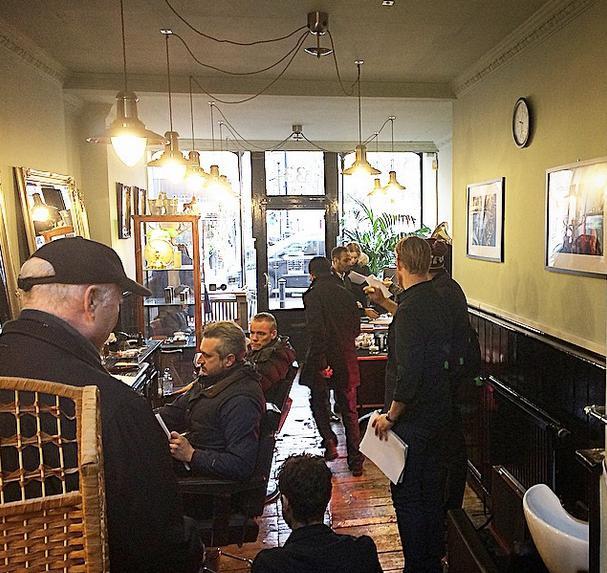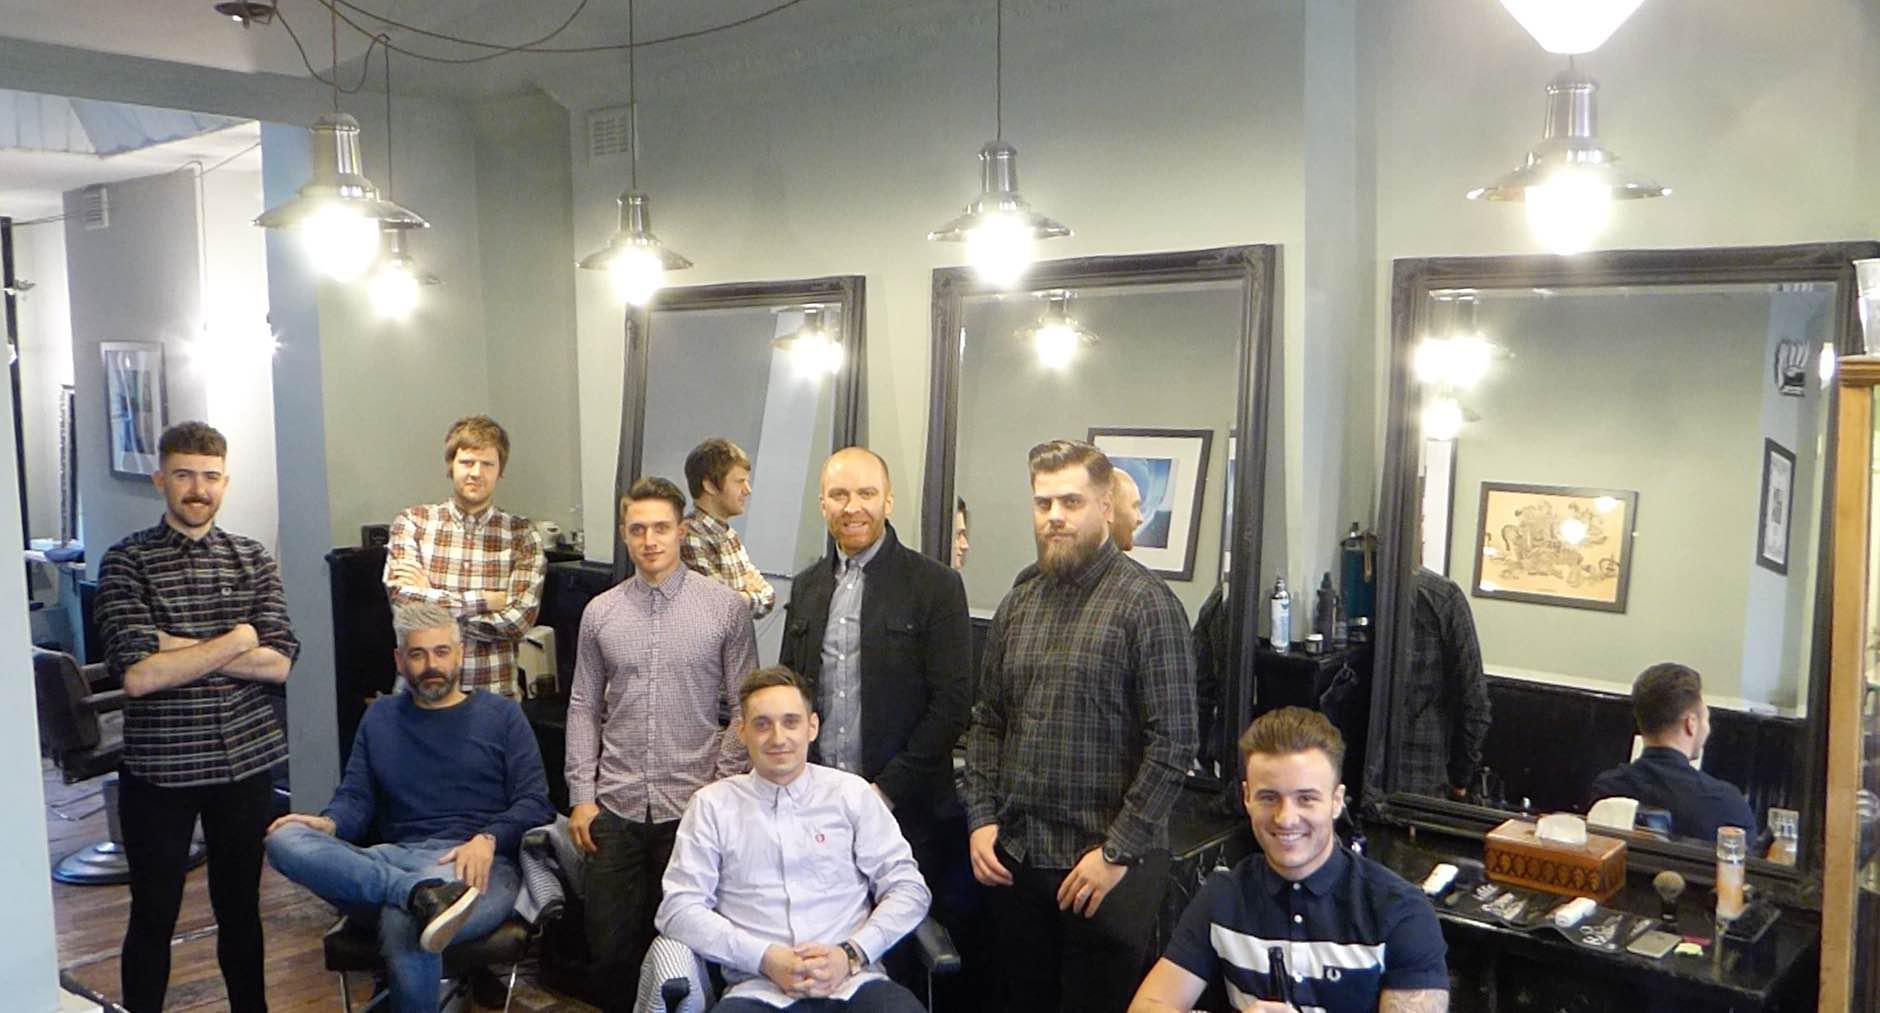The first image is the image on the left, the second image is the image on the right. Assess this claim about the two images: "There are exactly two people in the left image.". Correct or not? Answer yes or no. No. 